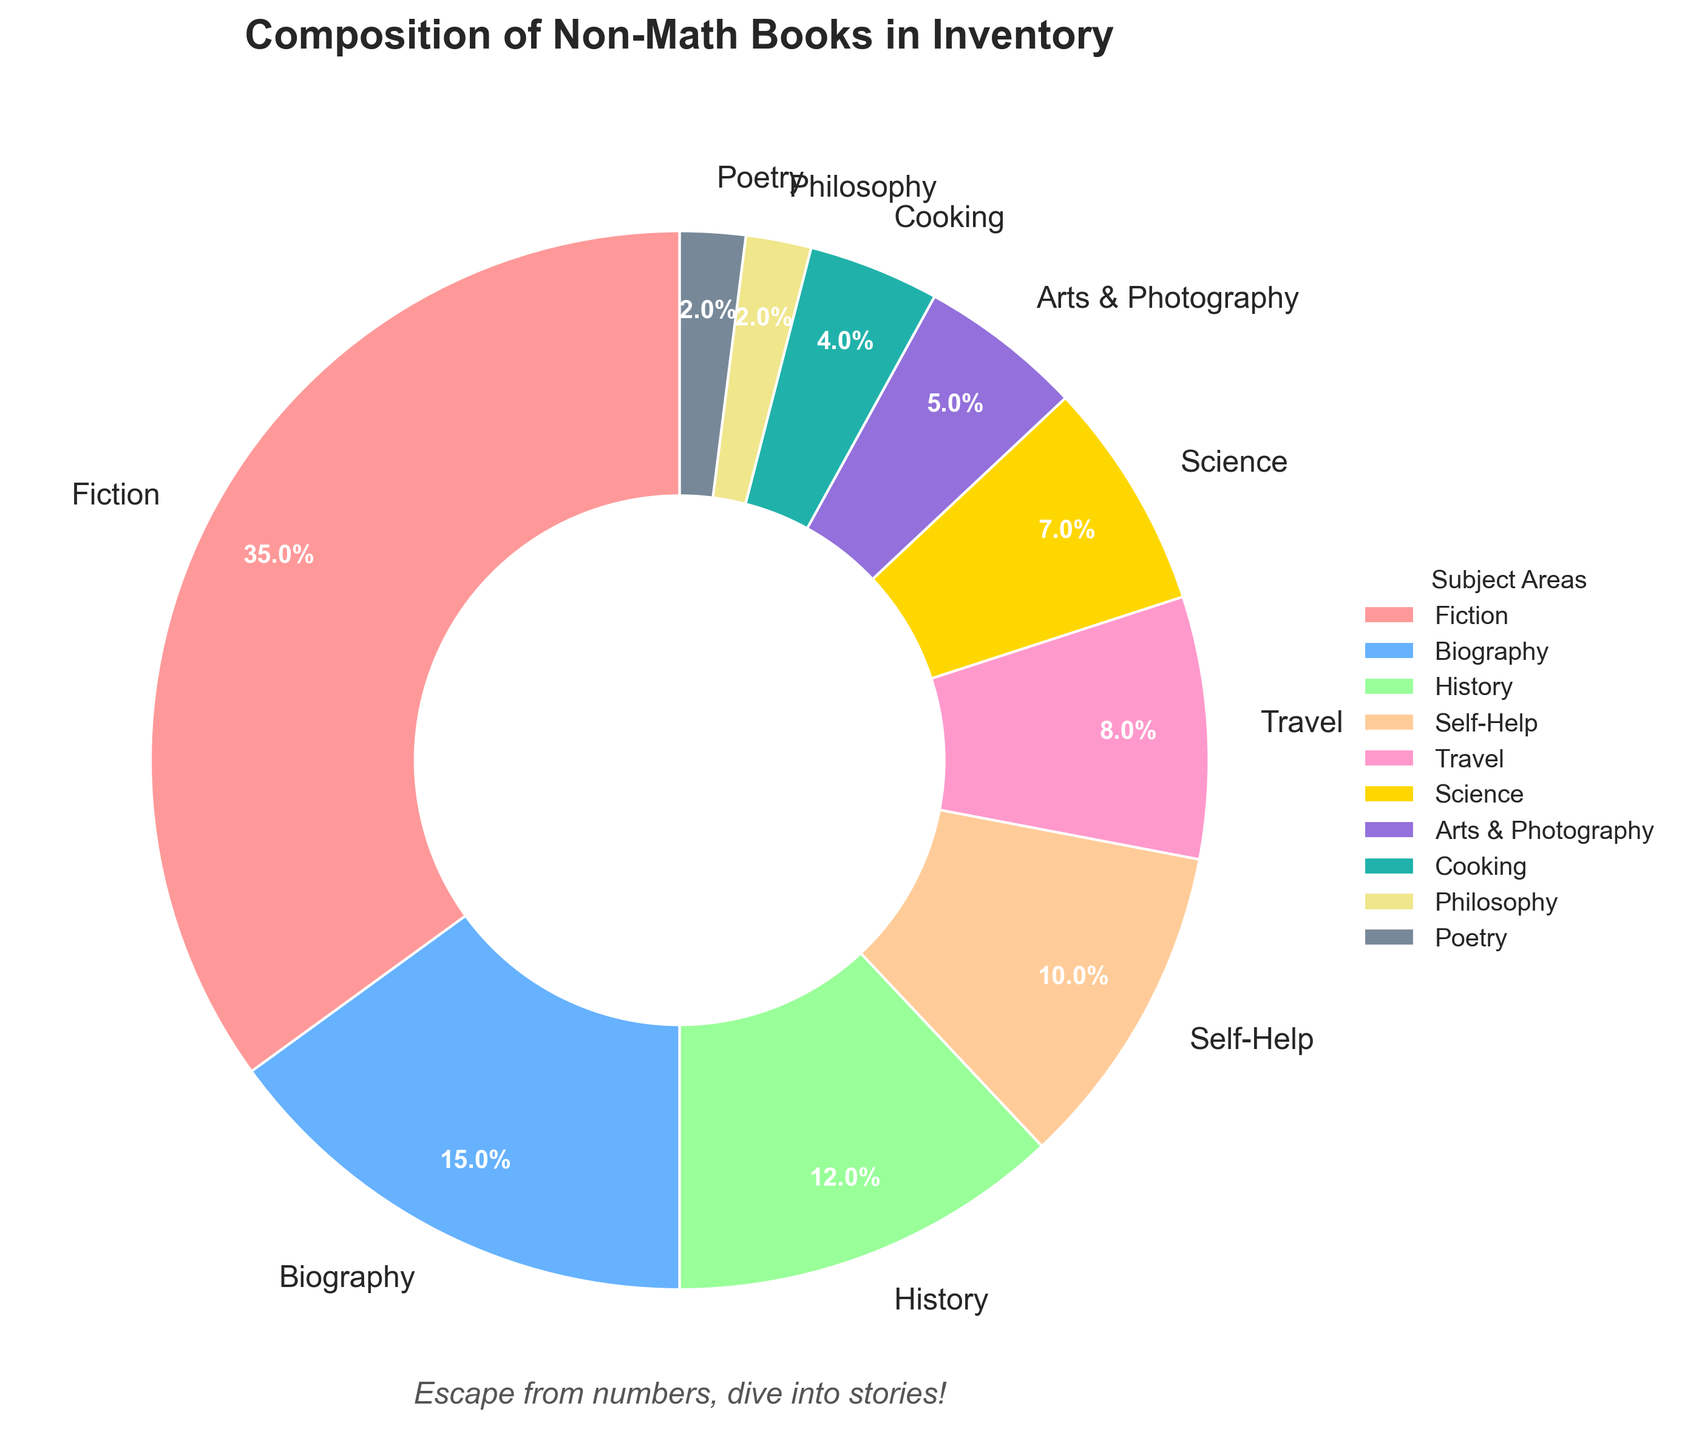Which subject area has the largest proportion of non-math books? The pie chart shows that the largest segment is for Fiction books, making up 35% of the inventory.
Answer: Fiction Which subject area accounts for a larger percentage, History or Biography books? The pie chart displays 15% for Biography and 12% for History. Therefore, Biography accounts for a larger percentage.
Answer: Biography What is the combined percentage of Self-Help and Travel books? The chart shows that Self-Help books make up 10%, and Travel books make up 8%. Adding these together gives 10% + 8% = 18%.
Answer: 18% How much larger is the percentage of Fiction books compared to Science books? Fiction books are 35% of the inventory while Science books are 7%. The difference is 35% - 7% = 28%.
Answer: 28% Which subjects share the smallest proportion in the inventory? Both Poetry and Philosophy books cover 2% each of the inventory, making them the smallest segments.
Answer: Poetry and Philosophy Are there more Travel books or Cooking books in the inventory? The pie chart indicates that Travel books make up 8% of the inventory, while Cooking books make up 4%. Travel books thus have a larger proportion.
Answer: Travel Which subject areas together make up more than half of the non-math books in the inventory? Summing the largest segments from the pie chart: Fiction (35%), Biography (15%), and History (12%) together sum up to 35% + 15% + 12% = 62%, which is more than half.
Answer: Fiction, Biography, and History If you combine the percentages for Biography and Arts & Photography, does it exceed that of Science books? Biography books are 15%, and Arts & Photography books are 5%; their combined percentage is 15% + 5% = 20%, which exceeds Science books at 7%.
Answer: Yes Which color on the pie chart represents History books, and what is the percentage? History books are shown in a particular segment colored (interpreted from the given description of colors, usually '#FFCC99'), and the percentage is 12%.
Answer: 12% How much more popular are Fiction books compared to Arts & Photography books in the inventory? Fiction books make up 35% of the inventory, while Arts & Photography comprise 5%. The difference is 35% - 5% = 30%.
Answer: 30% 